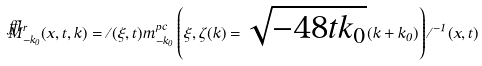<formula> <loc_0><loc_0><loc_500><loc_500>\breve { M } ^ { r } _ { - k _ { 0 } } ( x , t , k ) = \Xi ( \xi , t ) m ^ { p c } _ { - k _ { 0 } } \left ( \xi , \zeta ( k ) = \sqrt { - 4 8 t k _ { 0 } } ( k + k _ { 0 } ) \right ) \Xi ^ { - 1 } ( x , t )</formula> 